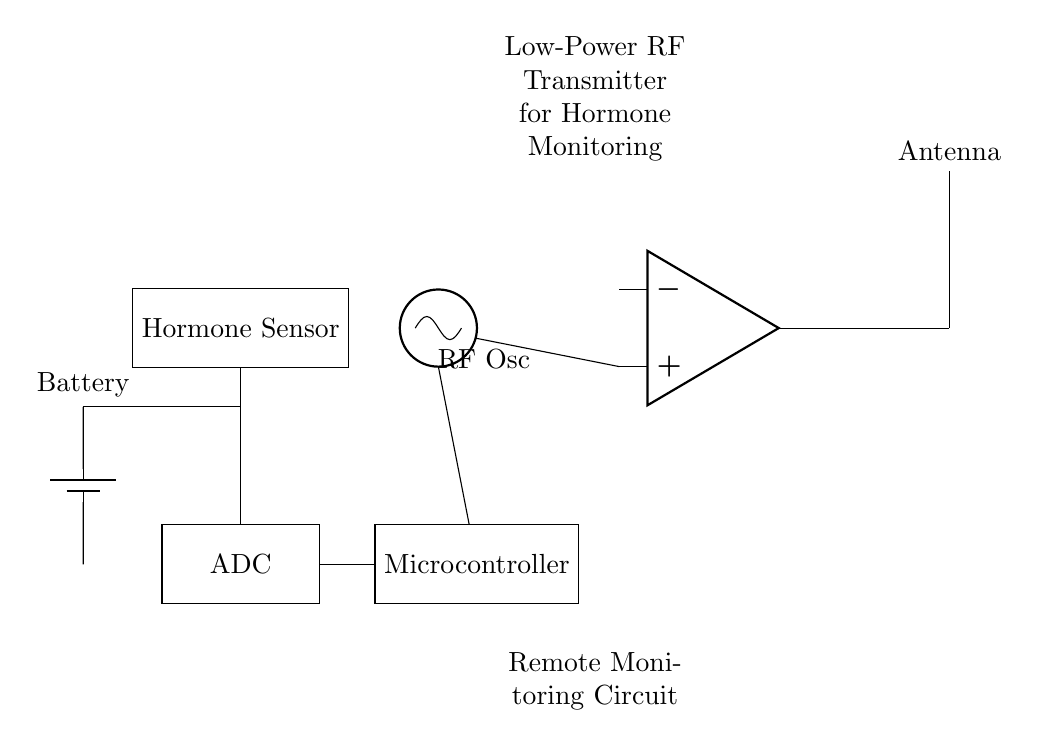What is the main function of the microcontroller in this circuit? The microcontroller processes the data received from the hormone sensor and controls the operation of the RF oscillator based on this data.
Answer: Data processing What component is used for hormone detection? The hormone sensor is specifically designed to detect hormone levels and send that information to the ADC for conversion.
Answer: Hormone Sensor What type of component is the oscillator? The RF oscillator is classified as an oscillator component, which generates the radio frequency signal needed for transmission.
Answer: Oscillator How does the hormone sensor connect to the ADC? The hormone sensor directly connects to the ADC through a wire, indicating a straightforward signal transfer from the sensor to the data converter stage.
Answer: Directly What is the purpose of the antenna in this circuit? The antenna is responsible for transmitting the RF signal carrying the data to a remote receiver, facilitating wireless monitoring of hormone levels.
Answer: Transmission Which component provides power to the circuit? The battery supplies power to the entire circuit, ensuring that all components have the necessary energy to operate effectively.
Answer: Battery 